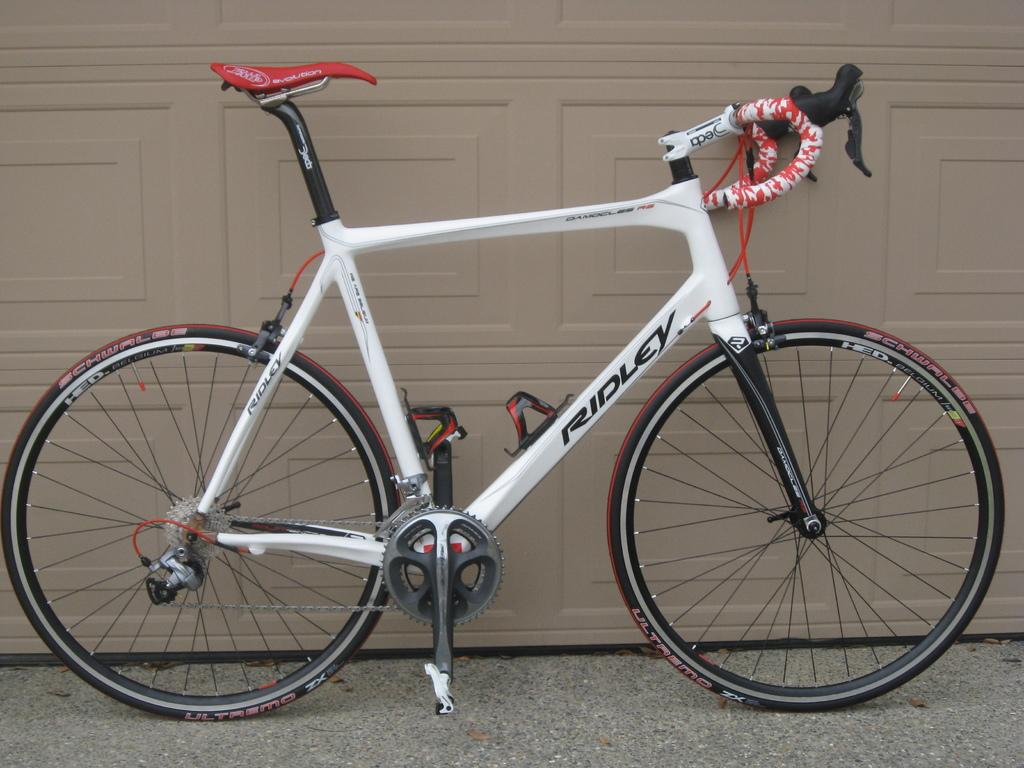What type of vehicle is in the image? There is a cycle in the image. Where is the cycle located? The cycle is parked on the road. What can be seen in the background of the image? There is a brown wall in the image. What type of shade is provided by the cycle in the image? The cycle does not provide any shade in the image, as it is parked and not being used to cover or protect anything. 